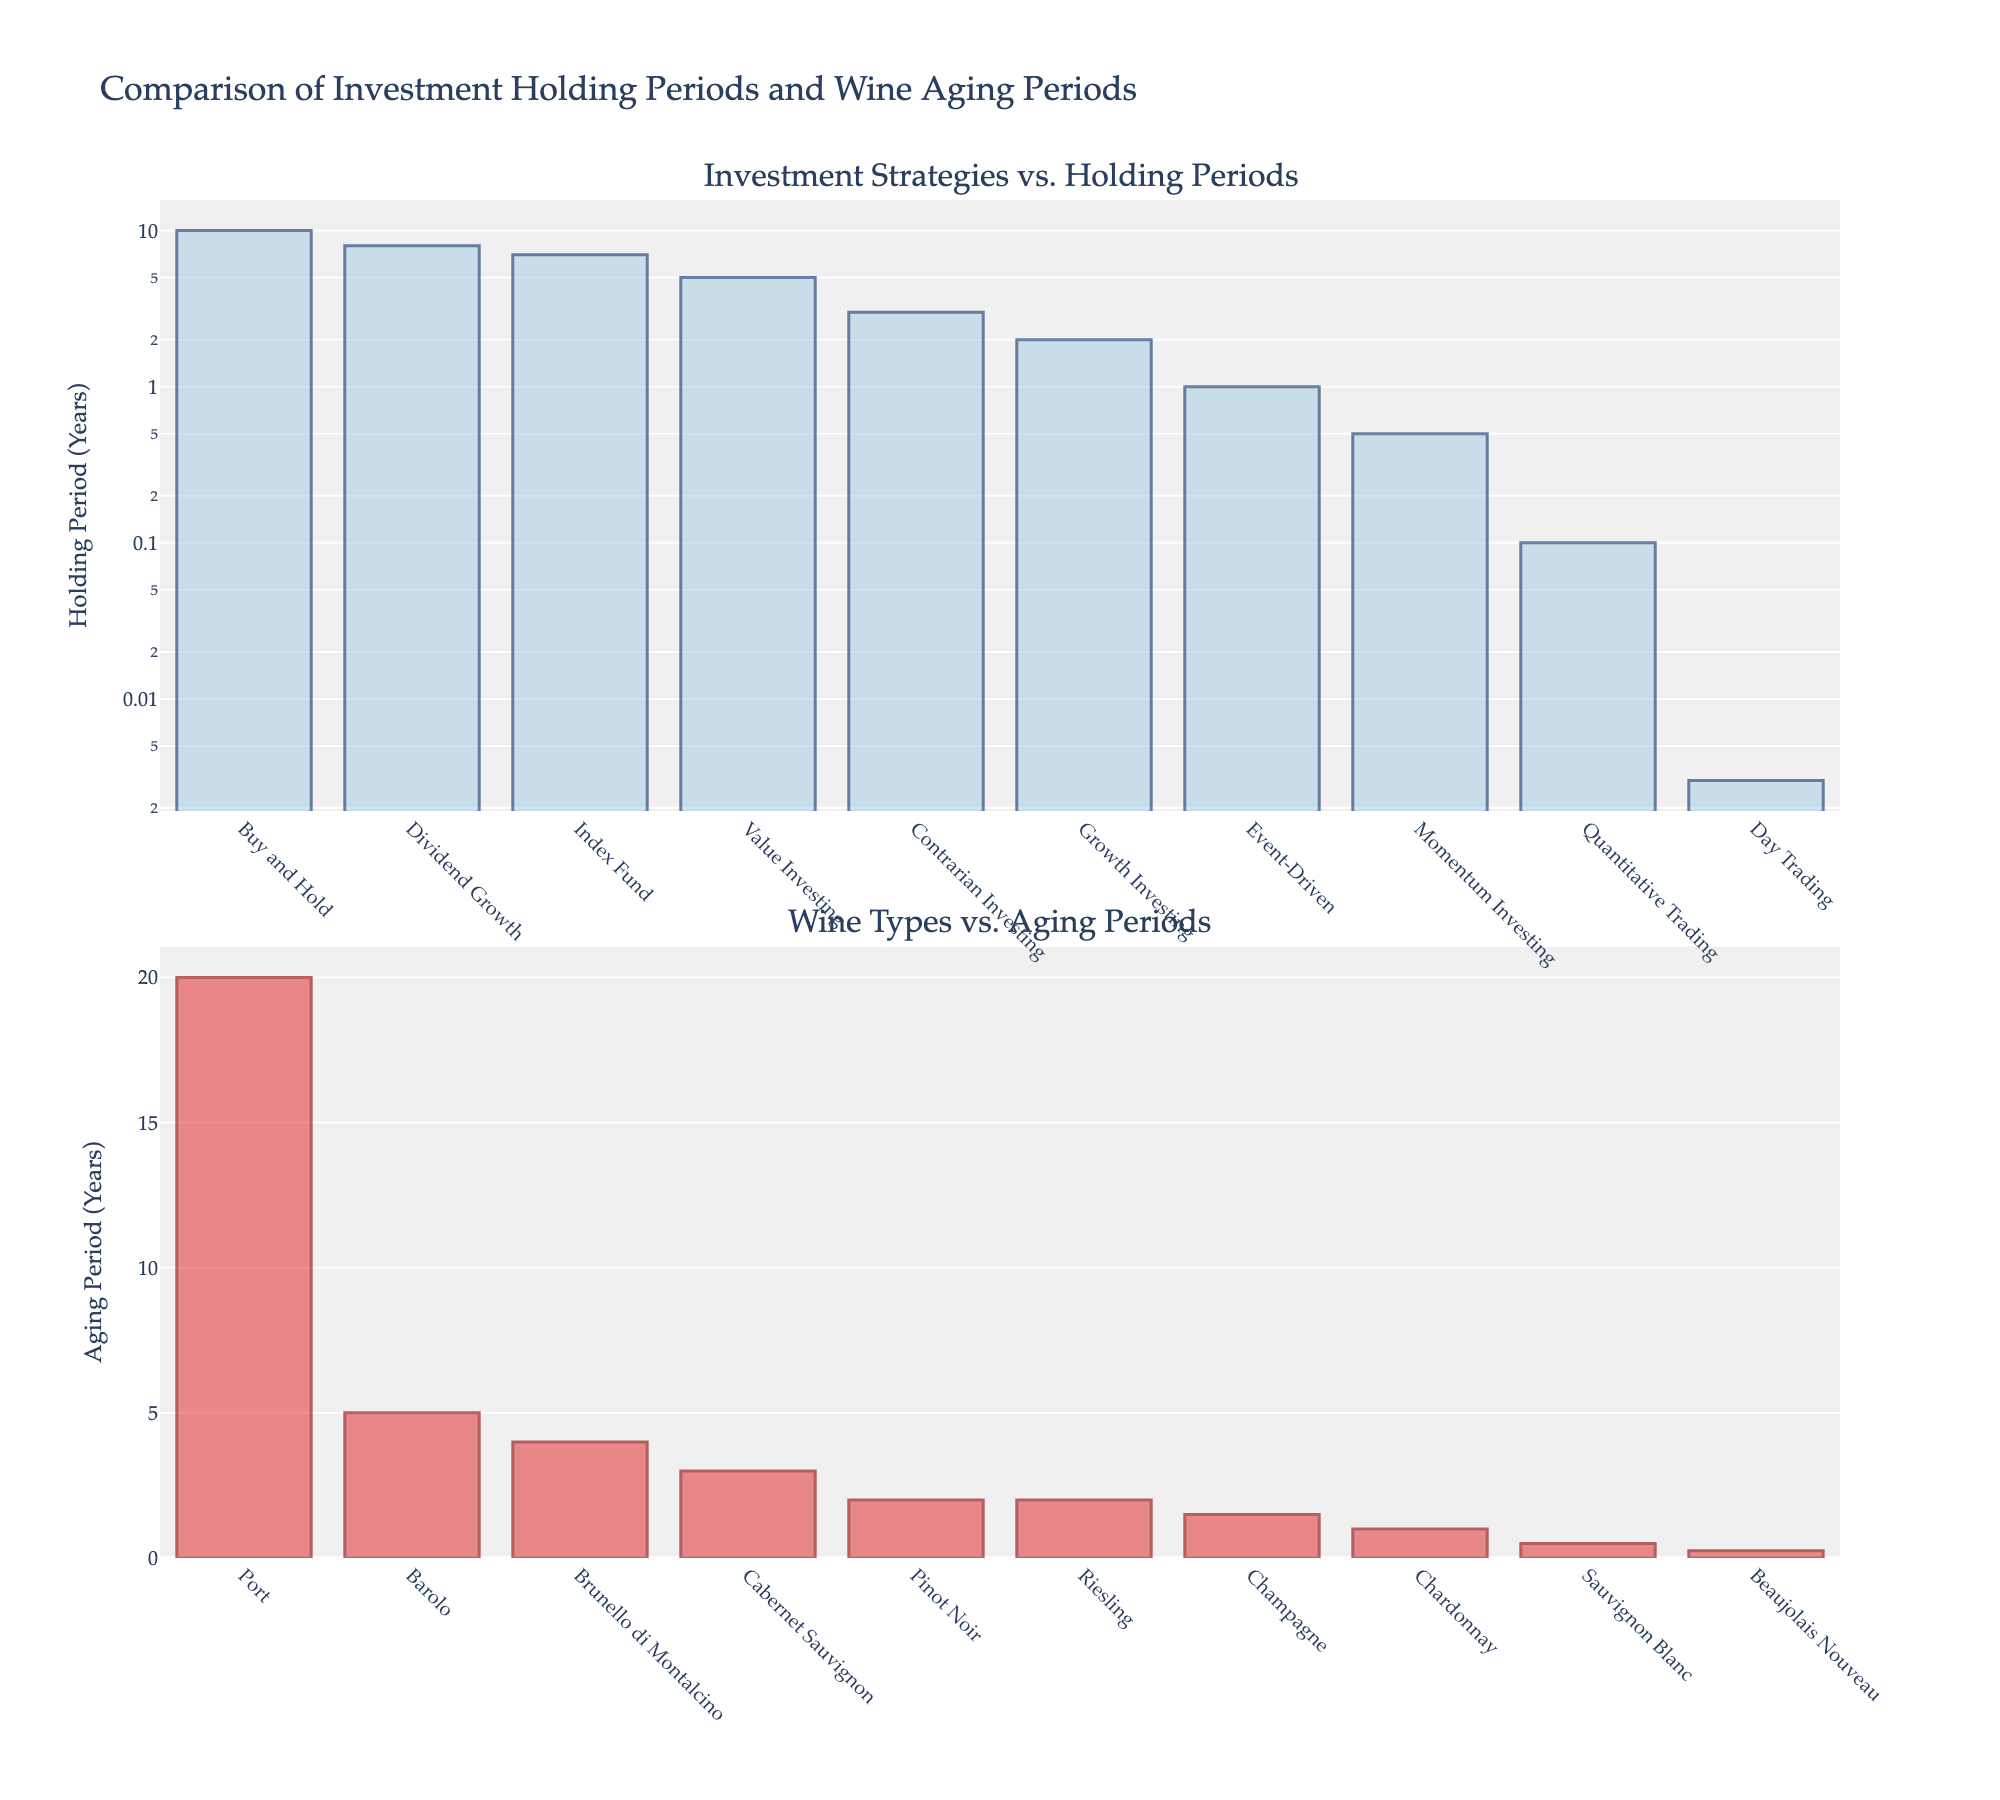What are the four indicators shown in the subplots? The four indicators are listed in the subplot titles: Phenolphthalein, Methyl Orange, Bromothymol Blue, and Universal Indicator.
Answer: Phenolphthalein, Methyl Orange, Bromothymol Blue, Universal Indicator Which indicator has the highest final pH value at 60 mL of titrant added? Look at the 60 mL point on each subplot and compare the pH values. The highest value is observed in the Phenolphthalein subplot.
Answer: Phenolphthalein What is the pH range for the Methyl Orange indicator? Check the minimum and maximum pH values on the Methyl Orange subplot from 0 to 60 mL. The range is from 3.2 to 10.6.
Answer: 3.2 to 10.6 At what volume of titrant does the Universal Indicator reach a pH of 7? Locate the Universal Indicator subplot and find where the pH value equals 7. This occurs around 45 mL.
Answer: 45 mL How does the pH change for Phenolphthalein between 5 mL and 50 mL of titrant? Examine the Phenolphthalein subplot and calculate the difference in pH values at these points: pH (50 mL) - pH (5 mL) = 10.5 - 2.3.
Answer: 8.2 For which indicator does the pH value increase the least between 10 mL and 60 mL of titrant? Look at the change in pH from 10 mL to 60 mL for each indicator. Bromothymol Blue changes the least from 7.1 to 10.1, a difference of 3.
Answer: Bromothymol Blue Which indicator shows the most gradual increase in pH over the range of volumes? Assess the slope of the pH lines on each subplot. Methyl Orange has a more gradual increase compared to the sharp increases of the other indicators.
Answer: Methyl Orange At approximately what volume do all indicators achieve a pH of at least 7? Check each subplot and determine when each line crosses a pH value of 7. This occurs around 35-40 mL for all subplots.
Answer: 35-40 mL 